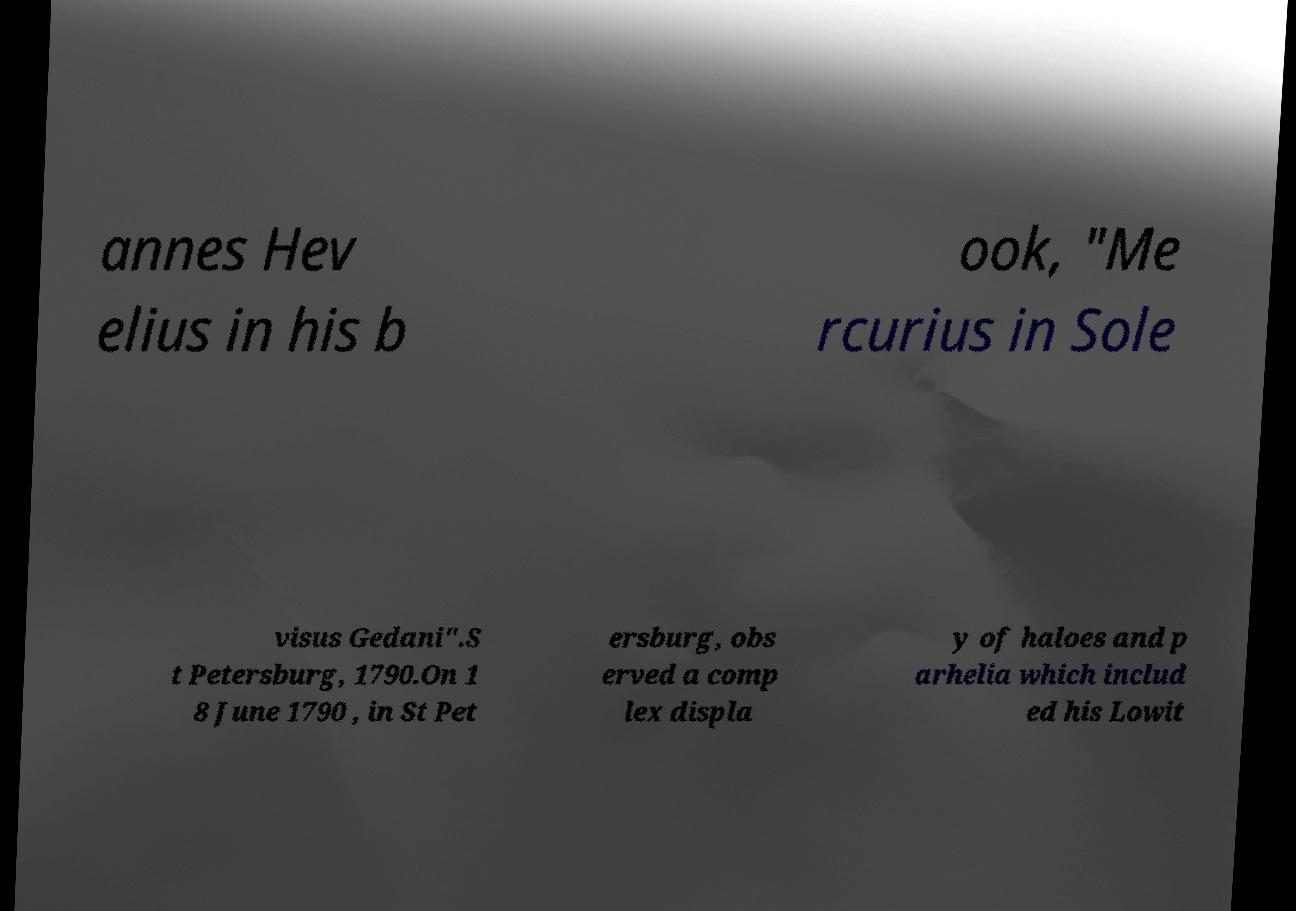Can you read and provide the text displayed in the image?This photo seems to have some interesting text. Can you extract and type it out for me? annes Hev elius in his b ook, "Me rcurius in Sole visus Gedani".S t Petersburg, 1790.On 1 8 June 1790 , in St Pet ersburg, obs erved a comp lex displa y of haloes and p arhelia which includ ed his Lowit 